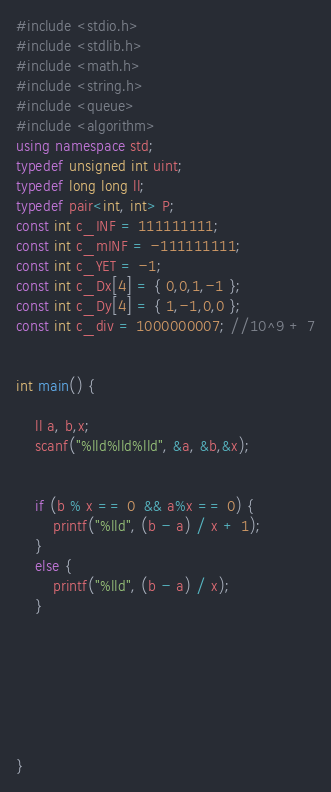<code> <loc_0><loc_0><loc_500><loc_500><_C++_>#include <stdio.h>
#include <stdlib.h>
#include <math.h>
#include <string.h>
#include <queue>
#include <algorithm>
using namespace std;
typedef unsigned int uint;
typedef long long ll;
typedef pair<int, int> P;
const int c_INF = 111111111;
const int c_mINF = -111111111;
const int c_YET = -1;
const int c_Dx[4] = { 0,0,1,-1 };
const int c_Dy[4] = { 1,-1,0,0 };
const int c_div = 1000000007; //10^9 + 7


int main() {

	ll a, b,x;
	scanf("%lld%lld%lld", &a, &b,&x);


	if (b % x == 0  && a%x == 0) {
		printf("%lld", (b - a) / x + 1);
	}
	else {
		printf("%lld", (b - a) / x);
	}







}
</code> 